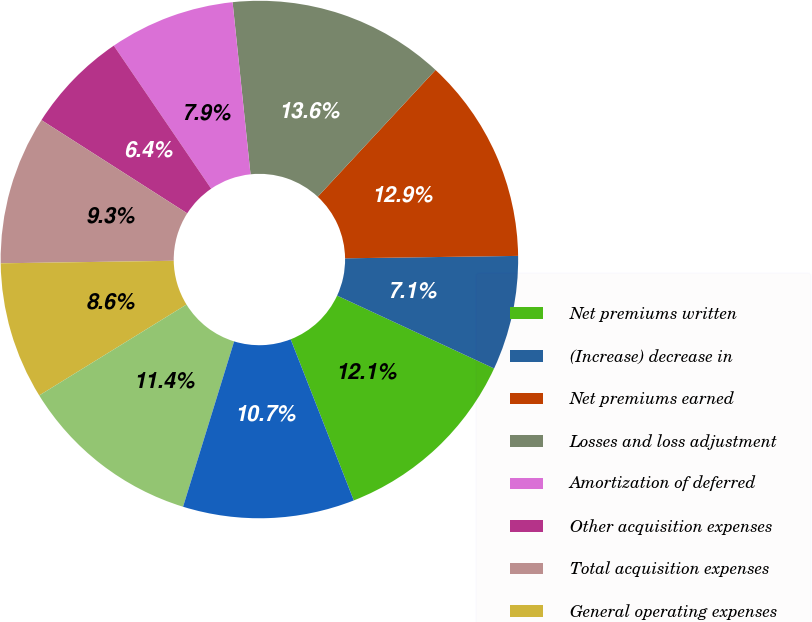<chart> <loc_0><loc_0><loc_500><loc_500><pie_chart><fcel>Net premiums written<fcel>(Increase) decrease in<fcel>Net premiums earned<fcel>Losses and loss adjustment<fcel>Amortization of deferred<fcel>Other acquisition expenses<fcel>Total acquisition expenses<fcel>General operating expenses<fcel>Underwriting loss<fcel>Net investment income<nl><fcel>12.14%<fcel>7.14%<fcel>12.86%<fcel>13.57%<fcel>7.86%<fcel>6.43%<fcel>9.29%<fcel>8.57%<fcel>11.43%<fcel>10.71%<nl></chart> 